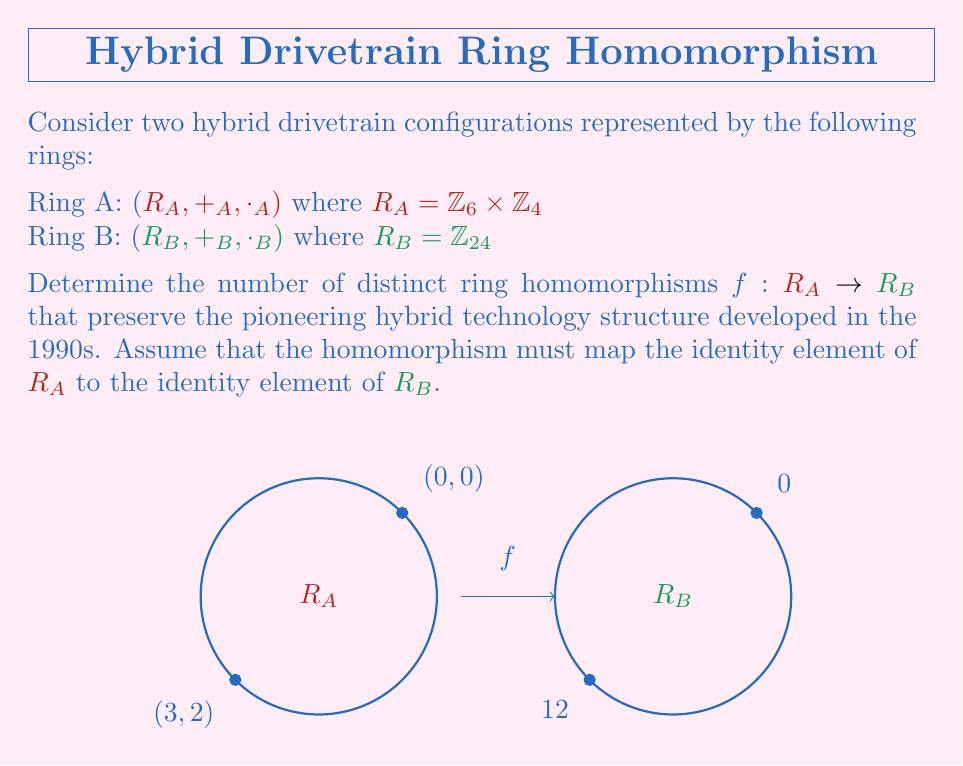Could you help me with this problem? Let's approach this step-by-step:

1) First, recall that a ring homomorphism $f: R_A \rightarrow R_B$ must satisfy:
   
   a) $f(a +_A b) = f(a) +_B f(b)$ for all $a,b \in R_A$
   b) $f(a \cdot_A b) = f(a) \cdot_B f(b)$ for all $a,b \in R_A$
   c) $f(1_A) = 1_B$ where $1_A$ and $1_B$ are the multiplicative identities

2) In $R_A = \mathbb{Z}_6 \times \mathbb{Z}_4$, the identity element is $(0,0)$. In $R_B = \mathbb{Z}_{24}$, the identity element is $0$.

3) To determine a homomorphism, we need to find the images of the generators of $R_A$. The generators are $(1,0)$ and $(0,1)$.

4) Let $f((1,0)) = a$ and $f((0,1)) = b$ where $a,b \in \mathbb{Z}_{24}$.

5) Since $(1,0)$ has order 6 in $R_A$, $f((1,0))$ must have order that divides 6 in $R_B$. The elements in $\mathbb{Z}_{24}$ with order dividing 6 are 0, 4, 8, 12, 16, 20.

6) Similarly, since $(0,1)$ has order 4 in $R_A$, $f((0,1))$ must have order that divides 4 in $R_B$. The elements in $\mathbb{Z}_{24}$ with order dividing 4 are 0, 6, 12, 18.

7) However, we can't choose 0 for either $a$ or $b$, as this would not generate all elements of $R_A$.

8) Therefore, the possible values for $a$ are 4, 8, 12, 16, 20, and the possible values for $b$ are 6, 12, 18.

9) For each choice of $a$ and $b$, we get a unique homomorphism defined by:

   $f((x,y)) = ax + by \mod 24$ for $(x,y) \in R_A$

10) Counting the possibilities:
    - If $a = 12$, $b$ can be 6 or 18 (2 options)
    - If $a = 4, 8, 16,$ or $20$, $b$ can only be 12 (4 options)

Therefore, there are $2 + 4 = 6$ distinct ring homomorphisms from $R_A$ to $R_B$.
Answer: 6 